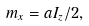<formula> <loc_0><loc_0><loc_500><loc_500>m _ { x } = a I _ { z } / 2 ,</formula> 